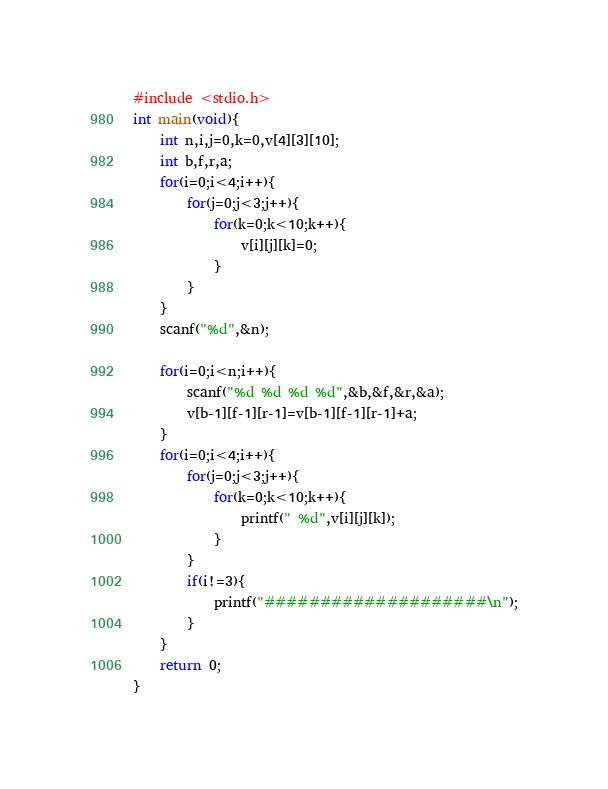<code> <loc_0><loc_0><loc_500><loc_500><_C_>#include <stdio.h>
int main(void){
    int n,i,j=0,k=0,v[4][3][10];
    int b,f,r,a;
    for(i=0;i<4;i++){
        for(j=0;j<3;j++){
            for(k=0;k<10;k++){
                v[i][j][k]=0;
            }
        }
    }
    scanf("%d",&n);
    
    for(i=0;i<n;i++){
        scanf("%d %d %d %d",&b,&f,&r,&a);
        v[b-1][f-1][r-1]=v[b-1][f-1][r-1]+a;
    }
    for(i=0;i<4;i++){
        for(j=0;j<3;j++){
            for(k=0;k<10;k++){
                printf(" %d",v[i][j][k]);
            }
        }
        if(i!=3){
            printf("####################\n");
        }
    }
    return 0;
}</code> 